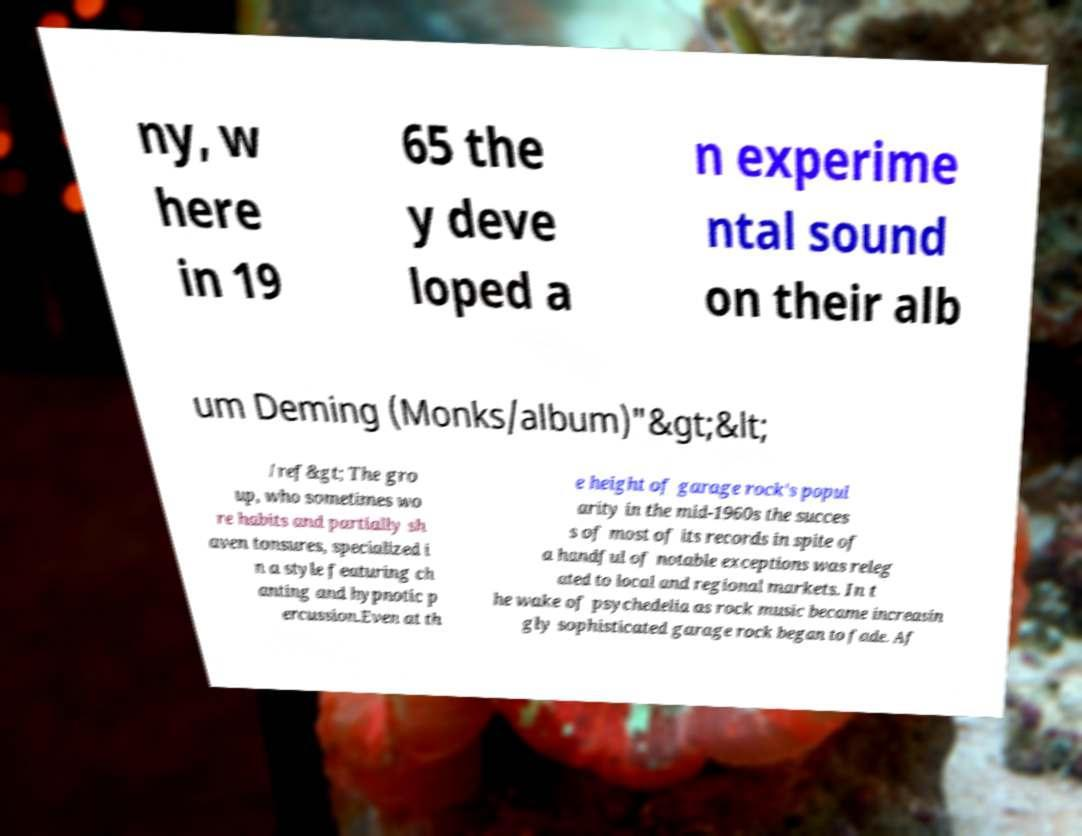Could you assist in decoding the text presented in this image and type it out clearly? ny, w here in 19 65 the y deve loped a n experime ntal sound on their alb um Deming (Monks/album)"&gt;&lt; /ref&gt; The gro up, who sometimes wo re habits and partially sh aven tonsures, specialized i n a style featuring ch anting and hypnotic p ercussion.Even at th e height of garage rock's popul arity in the mid-1960s the succes s of most of its records in spite of a handful of notable exceptions was releg ated to local and regional markets. In t he wake of psychedelia as rock music became increasin gly sophisticated garage rock began to fade. Af 